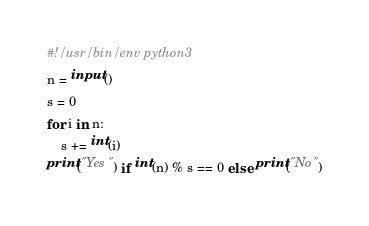<code> <loc_0><loc_0><loc_500><loc_500><_Python_>#!/usr/bin/env python3
n = input()
s = 0
for i in n:
    s += int(i)
print("Yes") if int(n) % s == 0 else print("No")</code> 